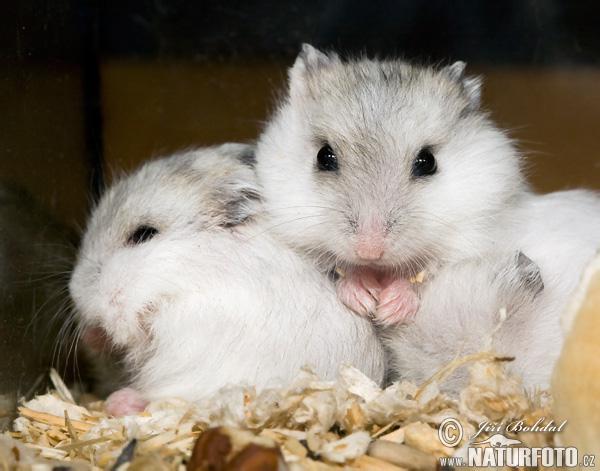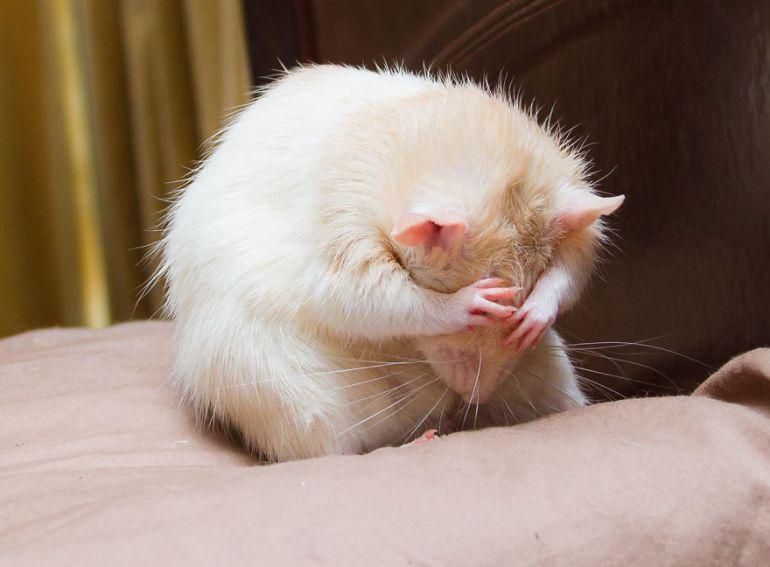The first image is the image on the left, the second image is the image on the right. Given the left and right images, does the statement "An image shows one rodent pet lying with its belly flat on a light-colored wood surface." hold true? Answer yes or no. No. The first image is the image on the left, the second image is the image on the right. Considering the images on both sides, is "A rodent is lying across a flat glossy surface in one of the images." valid? Answer yes or no. No. 